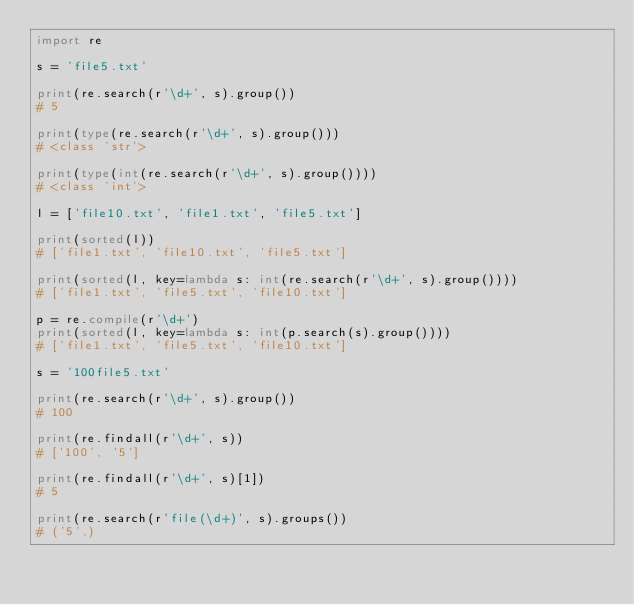<code> <loc_0><loc_0><loc_500><loc_500><_Python_>import re

s = 'file5.txt'

print(re.search(r'\d+', s).group())
# 5

print(type(re.search(r'\d+', s).group()))
# <class 'str'>

print(type(int(re.search(r'\d+', s).group())))
# <class 'int'>

l = ['file10.txt', 'file1.txt', 'file5.txt']

print(sorted(l))
# ['file1.txt', 'file10.txt', 'file5.txt']

print(sorted(l, key=lambda s: int(re.search(r'\d+', s).group())))
# ['file1.txt', 'file5.txt', 'file10.txt']

p = re.compile(r'\d+')
print(sorted(l, key=lambda s: int(p.search(s).group())))
# ['file1.txt', 'file5.txt', 'file10.txt']

s = '100file5.txt'

print(re.search(r'\d+', s).group())
# 100

print(re.findall(r'\d+', s))
# ['100', '5']

print(re.findall(r'\d+', s)[1])
# 5

print(re.search(r'file(\d+)', s).groups())
# ('5',)
</code> 